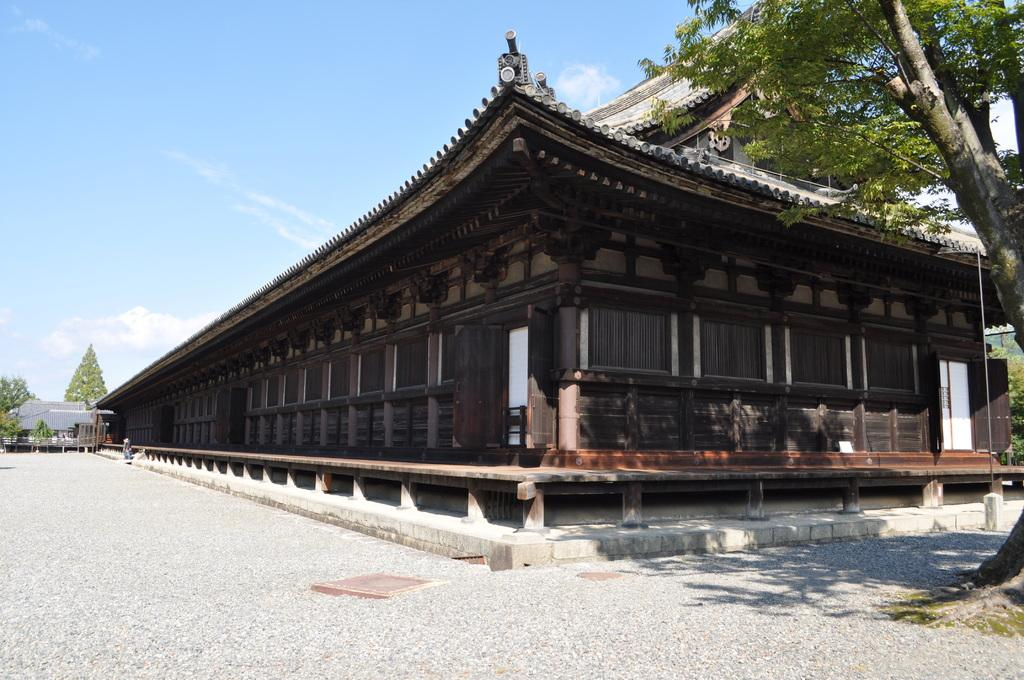What type of structure is visible in the image? There is a building in the image. What feature can be seen on the building? The building has windows. What type of vegetation is present in the image? There are trees in the image. What colors are visible in the sky in the image? The sky is blue and white in color. What type of trousers is the building wearing in the image? Buildings do not wear trousers, as they are inanimate objects. 